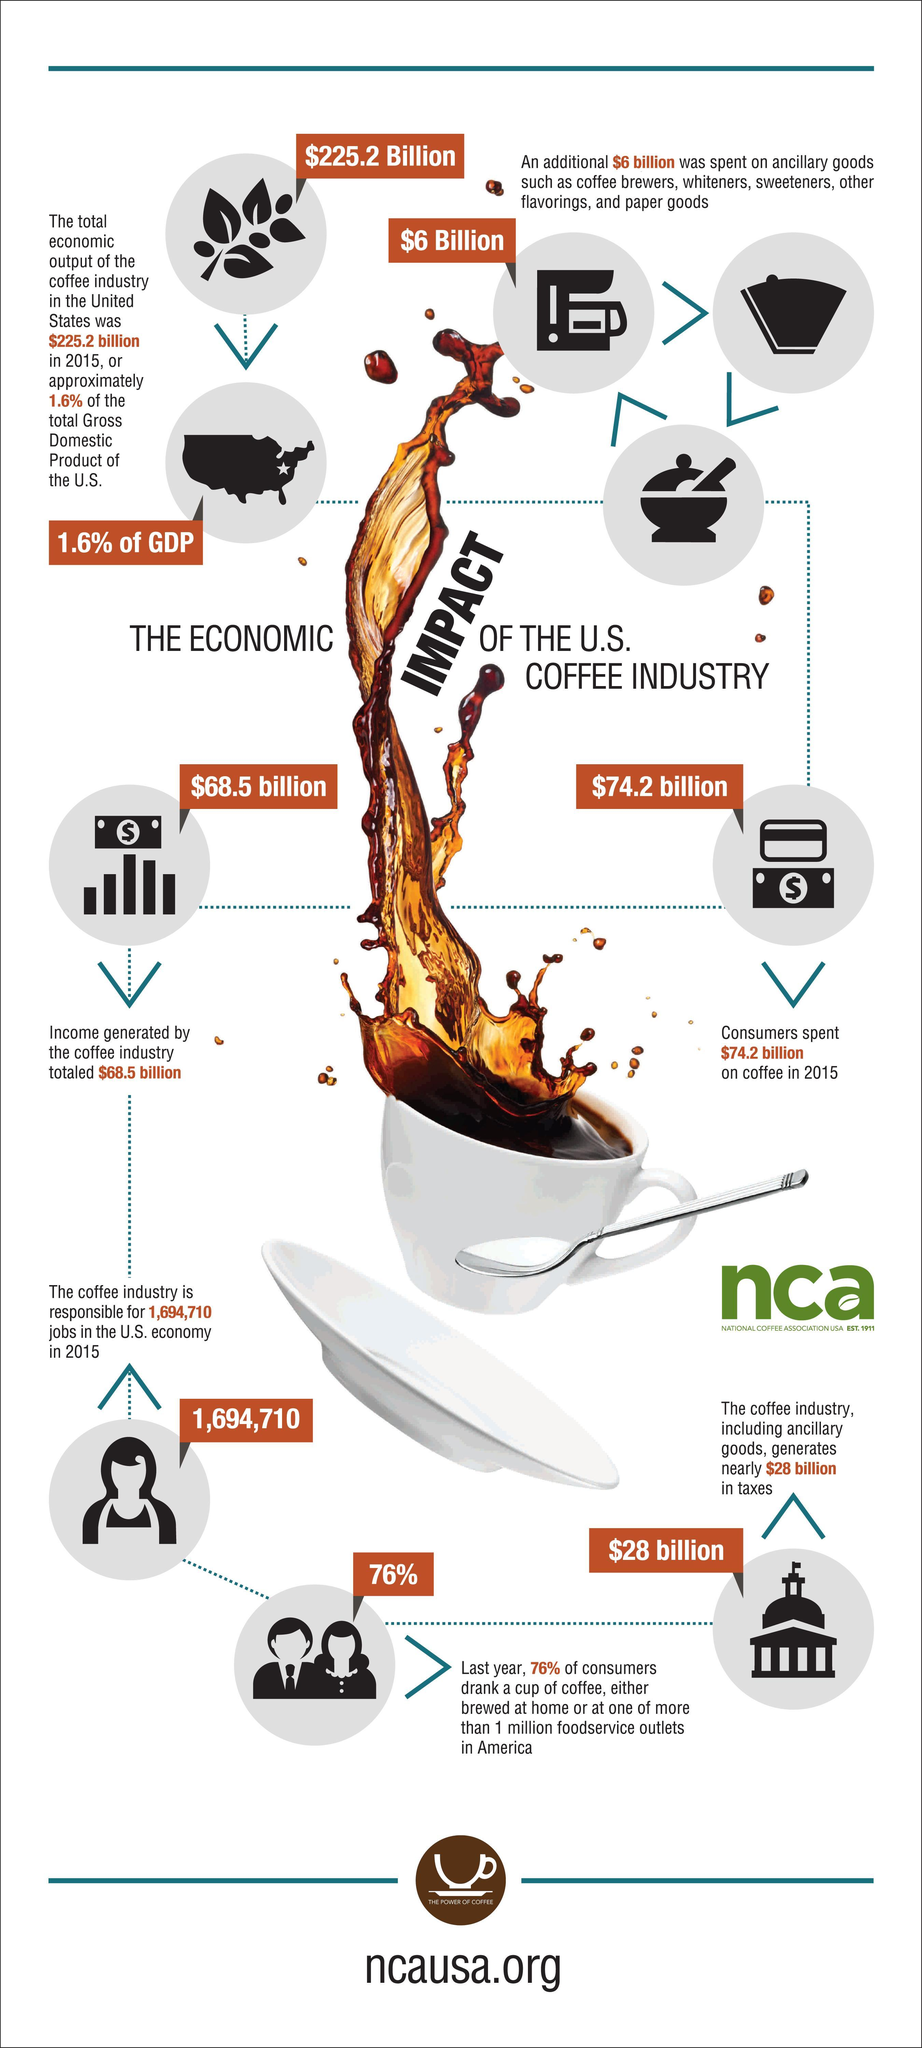What is the number of jobs created by the Coffee Industry in the U.S. in 2015?
Answer the question with a short phrase. 1,694,710 What is the income generated by the coffee industry in the U.S. in 2015? $68.5 billion How much did the consumers spend on coffee in the U.S. in 2015? $74.2 billion What percentage of the total GDP of the U.S. was contributed by the coffee industry? 1.6% 